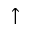<formula> <loc_0><loc_0><loc_500><loc_500>\uparrow</formula> 